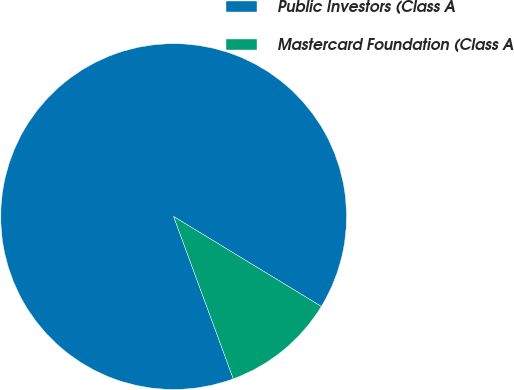Convert chart to OTSL. <chart><loc_0><loc_0><loc_500><loc_500><pie_chart><fcel>Public Investors (Class A<fcel>Mastercard Foundation (Class A<nl><fcel>89.31%<fcel>10.69%<nl></chart> 